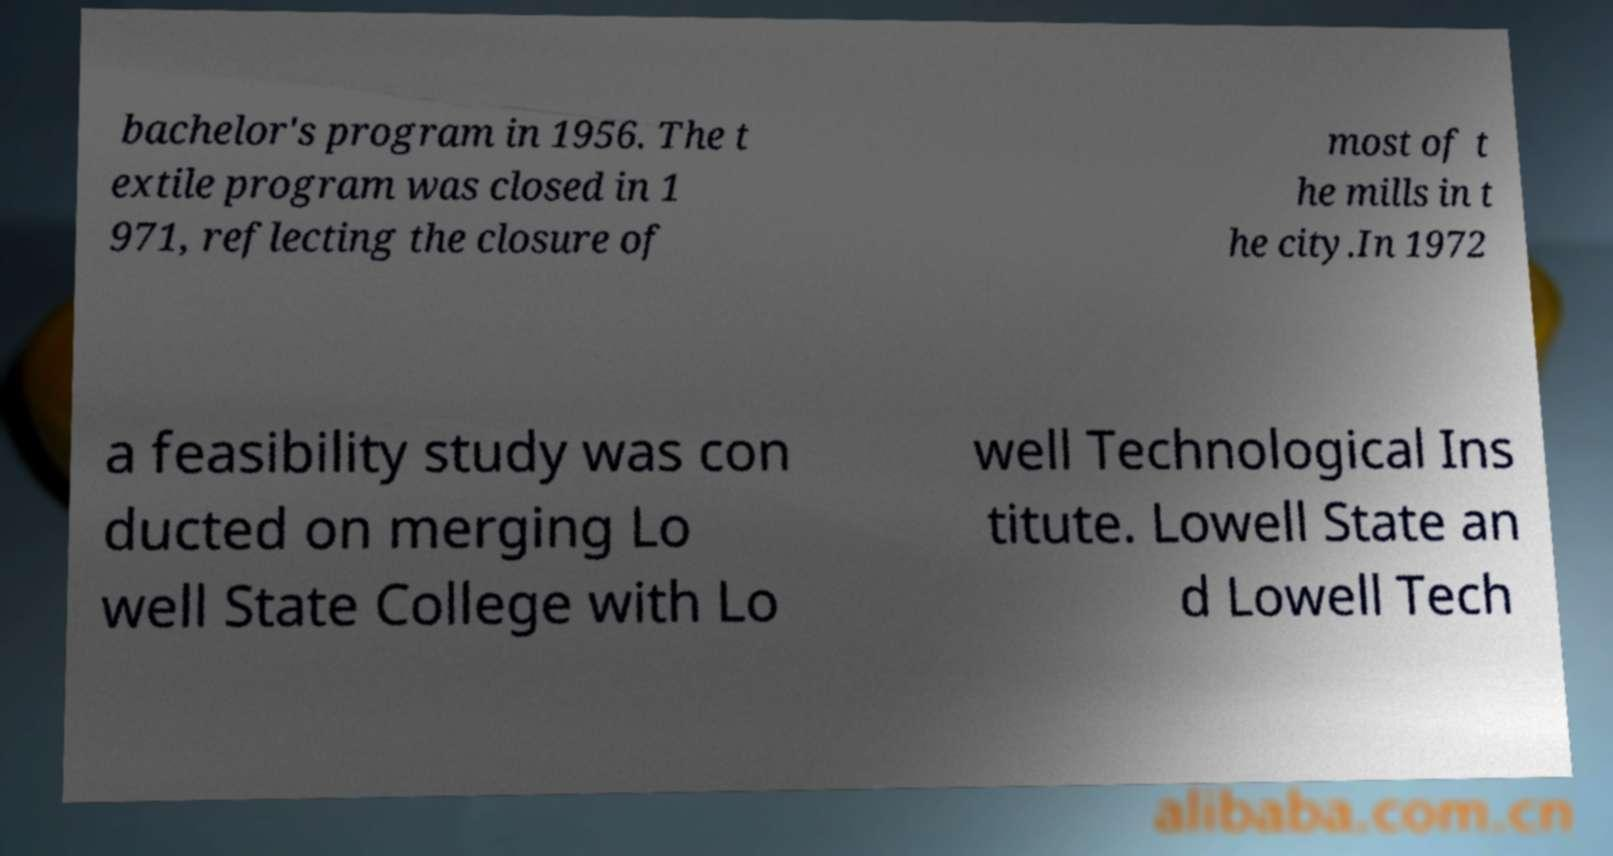For documentation purposes, I need the text within this image transcribed. Could you provide that? bachelor's program in 1956. The t extile program was closed in 1 971, reflecting the closure of most of t he mills in t he city.In 1972 a feasibility study was con ducted on merging Lo well State College with Lo well Technological Ins titute. Lowell State an d Lowell Tech 